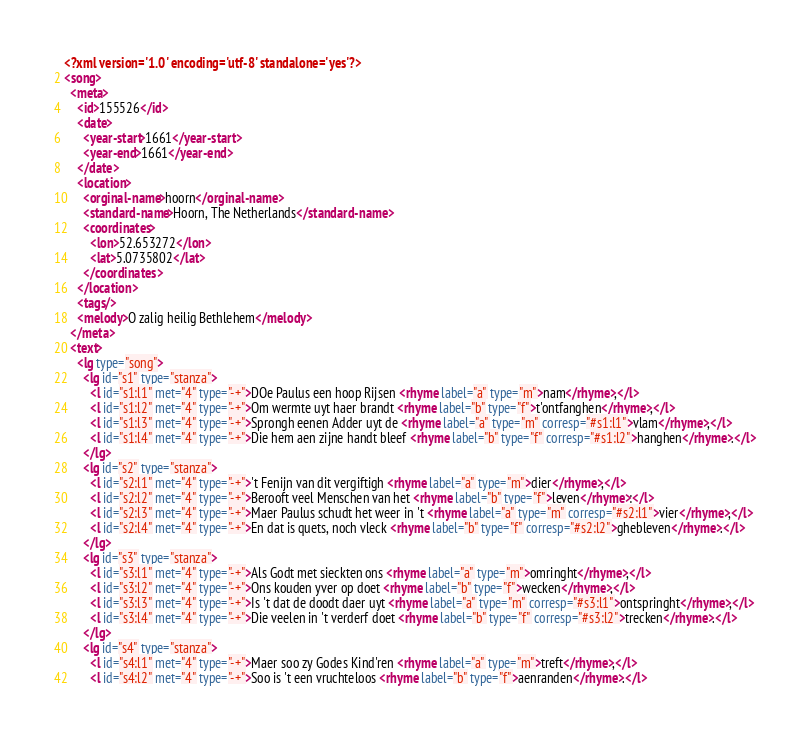Convert code to text. <code><loc_0><loc_0><loc_500><loc_500><_XML_><?xml version='1.0' encoding='utf-8' standalone='yes'?>
<song>
  <meta>
    <id>155526</id>
    <date>
      <year-start>1661</year-start>
      <year-end>1661</year-end>
    </date>
    <location>
      <orginal-name>hoorn</orginal-name>
      <standard-name>Hoorn, The Netherlands</standard-name>
      <coordinates>
        <lon>52.653272</lon>
        <lat>5.0735802</lat>
      </coordinates>
    </location>
    <tags/>
    <melody>O zalig heilig Bethlehem</melody>
  </meta>
  <text>
    <lg type="song">
      <lg id="s1" type="stanza">
        <l id="s1:l1" met="4" type="-+">DOe Paulus een hoop Rijsen <rhyme label="a" type="m">nam</rhyme>,</l>
        <l id="s1:l2" met="4" type="-+">Om wermte uyt haer brandt <rhyme label="b" type="f">t'ontfanghen</rhyme>,</l>
        <l id="s1:l3" met="4" type="-+">Sprongh eenen Adder uyt de <rhyme label="a" type="m" corresp="#s1:l1">vlam</rhyme>,</l>
        <l id="s1:l4" met="4" type="-+">Die hem aen zijne handt bleef <rhyme label="b" type="f" corresp="#s1:l2">hanghen</rhyme>.</l>
      </lg>
      <lg id="s2" type="stanza">
        <l id="s2:l1" met="4" type="-+">'t Fenijn van dit vergiftigh <rhyme label="a" type="m">dier</rhyme>,</l>
        <l id="s2:l2" met="4" type="-+">Berooft veel Menschen van het <rhyme label="b" type="f">leven</rhyme>:</l>
        <l id="s2:l3" met="4" type="-+">Maer Paulus schudt het weer in 't <rhyme label="a" type="m" corresp="#s2:l1">vier</rhyme>,</l>
        <l id="s2:l4" met="4" type="-+">En dat is quets, noch vleck <rhyme label="b" type="f" corresp="#s2:l2">ghebleven</rhyme>.</l>
      </lg>
      <lg id="s3" type="stanza">
        <l id="s3:l1" met="4" type="-+">Als Godt met sieckten ons <rhyme label="a" type="m">omringht</rhyme>,</l>
        <l id="s3:l2" met="4" type="-+">Ons kouden yver op doet <rhyme label="b" type="f">wecken</rhyme>,</l>
        <l id="s3:l3" met="4" type="-+">Is 't dat de doodt daer uyt <rhyme label="a" type="m" corresp="#s3:l1">ontspringht</rhyme>,</l>
        <l id="s3:l4" met="4" type="-+">Die veelen in 't verderf doet <rhyme label="b" type="f" corresp="#s3:l2">trecken</rhyme>.</l>
      </lg>
      <lg id="s4" type="stanza">
        <l id="s4:l1" met="4" type="-+">Maer soo zy Godes Kind'ren <rhyme label="a" type="m">treft</rhyme>,</l>
        <l id="s4:l2" met="4" type="-+">Soo is 't een vruchteloos <rhyme label="b" type="f">aenranden</rhyme>.</l></code> 